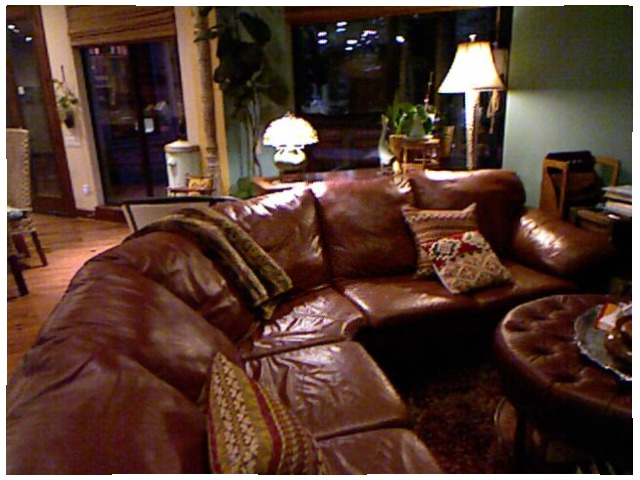<image>
Can you confirm if the cushion is on the sofa? No. The cushion is not positioned on the sofa. They may be near each other, but the cushion is not supported by or resting on top of the sofa. Is there a lamp behind the couch? Yes. From this viewpoint, the lamp is positioned behind the couch, with the couch partially or fully occluding the lamp. 